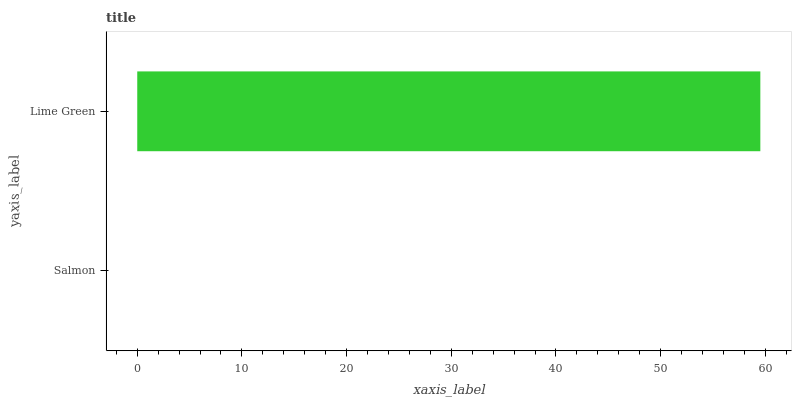Is Salmon the minimum?
Answer yes or no. Yes. Is Lime Green the maximum?
Answer yes or no. Yes. Is Lime Green the minimum?
Answer yes or no. No. Is Lime Green greater than Salmon?
Answer yes or no. Yes. Is Salmon less than Lime Green?
Answer yes or no. Yes. Is Salmon greater than Lime Green?
Answer yes or no. No. Is Lime Green less than Salmon?
Answer yes or no. No. Is Lime Green the high median?
Answer yes or no. Yes. Is Salmon the low median?
Answer yes or no. Yes. Is Salmon the high median?
Answer yes or no. No. Is Lime Green the low median?
Answer yes or no. No. 